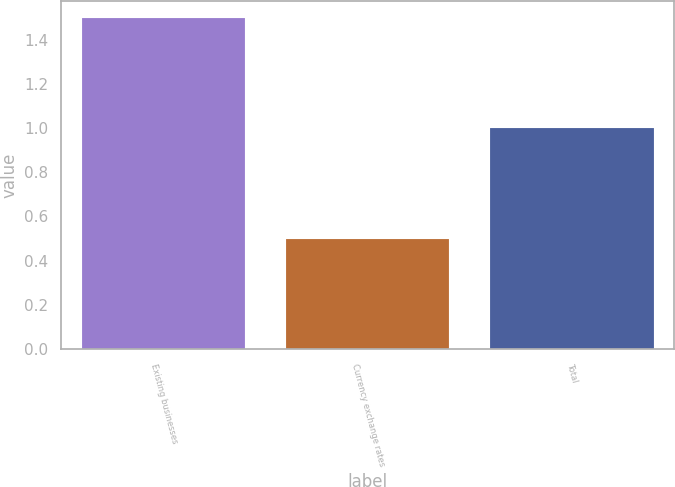Convert chart to OTSL. <chart><loc_0><loc_0><loc_500><loc_500><bar_chart><fcel>Existing businesses<fcel>Currency exchange rates<fcel>Total<nl><fcel>1.5<fcel>0.5<fcel>1<nl></chart> 